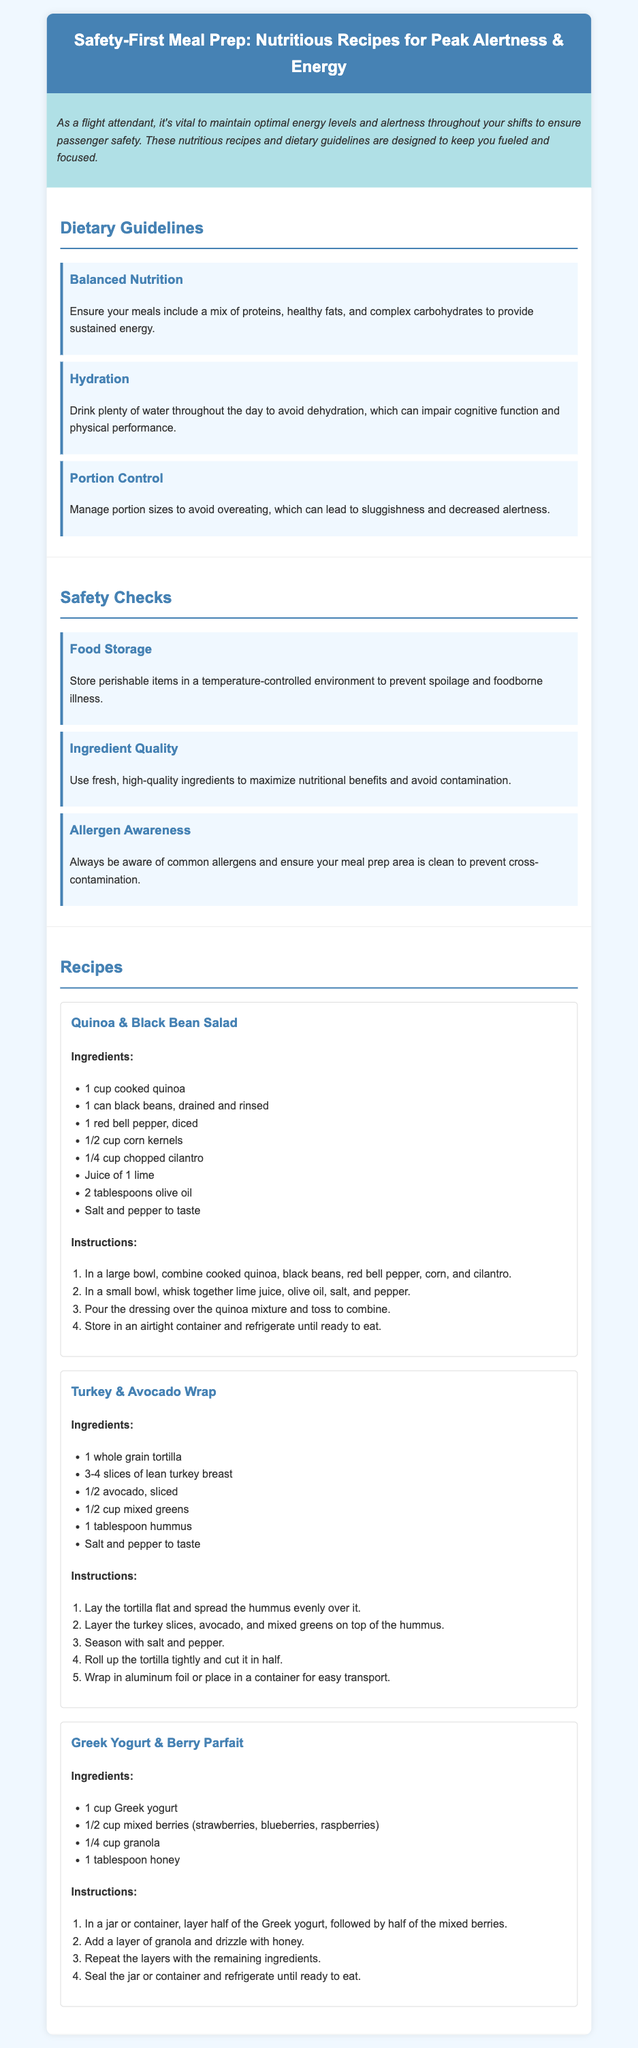What is the title of the document? The title of the document is mentioned at the top of the rendered content.
Answer: Safety-First Meal Prep: Nutritious Recipes for Peak Alertness & Energy What is included in the Quinoa & Black Bean Salad? The ingredients of the salad are listed below its title in the recipe section.
Answer: Quinoa, black beans, red bell pepper, corn, cilantro, lime juice, olive oil, salt, and pepper What is one of the dietary guidelines mentioned? The section on dietary guidelines lists several recommendations for meal preparation.
Answer: Balanced Nutrition How should ingredients be stored according to safety checks? The safety checks section provides specific instructions on how to handle food safely.
Answer: Temperature-controlled environment How many recipes are included in the document? The recipes are listed in the "Recipes" section after the guidelines and checks.
Answer: Three What type of wrap is suggested in one of the recipes? The name of the wrap is mentioned as part of the recipe titles.
Answer: Turkey & Avocado Wrap What is the recommended hydration measure? Hydration guidelines provide specific advice on fluid intake.
Answer: Drink plenty of water What should be done to avoid cross-contamination? The allergen awareness section outlines measures to maintain food safety.
Answer: Ensure your meal prep area is clean 